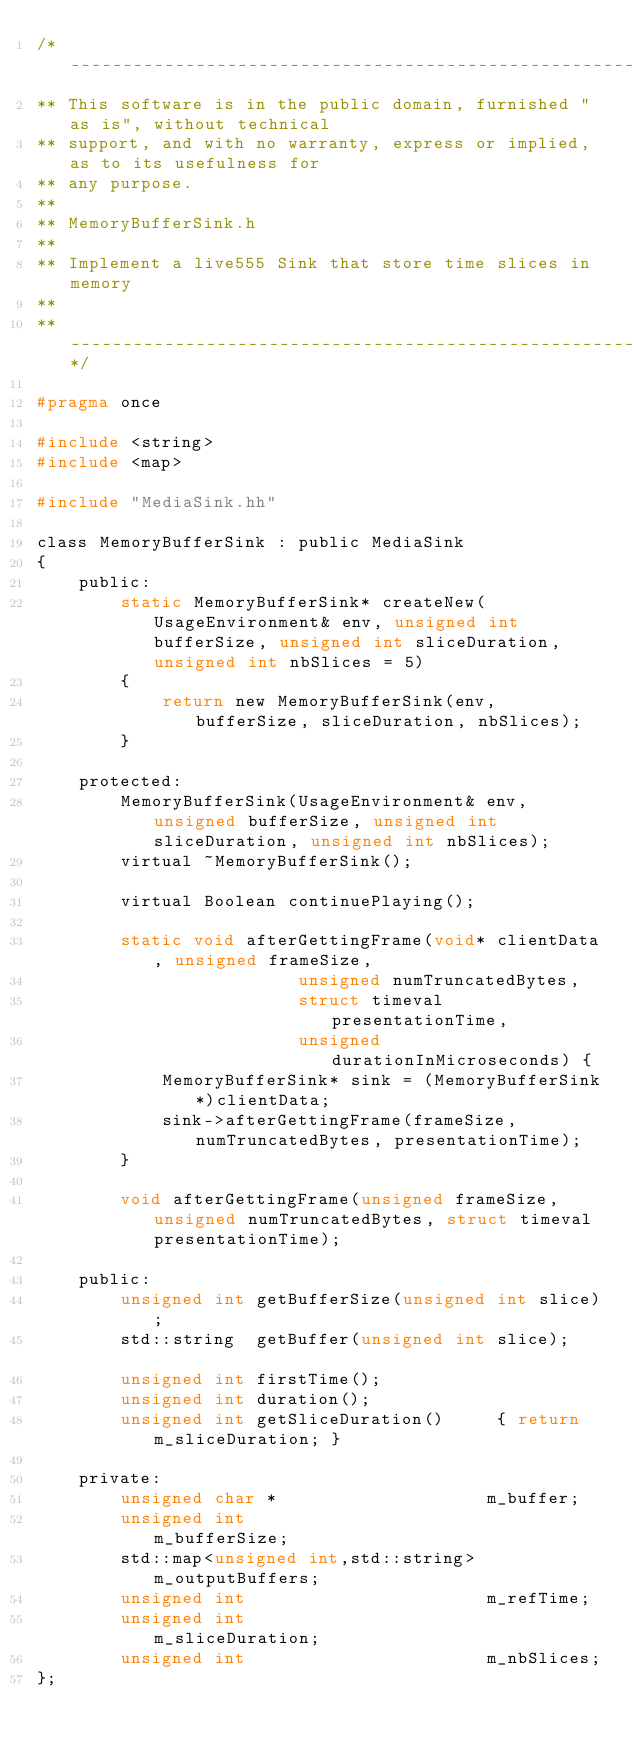<code> <loc_0><loc_0><loc_500><loc_500><_C_>/* ---------------------------------------------------------------------------
** This software is in the public domain, furnished "as is", without technical
** support, and with no warranty, express or implied, as to its usefulness for
** any purpose.
**
** MemoryBufferSink.h
** 
** Implement a live555 Sink that store time slices in memory
**
** -------------------------------------------------------------------------*/

#pragma once

#include <string>
#include <map>

#include "MediaSink.hh"

class MemoryBufferSink : public MediaSink
{
	public:
		static MemoryBufferSink* createNew(UsageEnvironment& env, unsigned int bufferSize, unsigned int sliceDuration, unsigned int nbSlices = 5) 
		{
			return new MemoryBufferSink(env, bufferSize, sliceDuration, nbSlices);
		}
		
	protected:
		MemoryBufferSink(UsageEnvironment& env, unsigned bufferSize, unsigned int sliceDuration, unsigned int nbSlices);
		virtual ~MemoryBufferSink(); 
		
		virtual Boolean continuePlaying();
	
		static void afterGettingFrame(void* clientData, unsigned frameSize,
						 unsigned numTruncatedBytes,
						 struct timeval presentationTime,
						 unsigned durationInMicroseconds) {
			MemoryBufferSink* sink = (MemoryBufferSink*)clientData;
			sink->afterGettingFrame(frameSize, numTruncatedBytes, presentationTime);
		}

		void afterGettingFrame(unsigned frameSize, unsigned numTruncatedBytes, struct timeval presentationTime);
		
	public:
		unsigned int getBufferSize(unsigned int slice);
		std::string  getBuffer(unsigned int slice);			
		unsigned int firstTime();
		unsigned int duration();
		unsigned int getSliceDuration() 	{ return m_sliceDuration; }
		
	private:
		unsigned char *                    m_buffer;
		unsigned int                       m_bufferSize;
		std::map<unsigned int,std::string> m_outputBuffers;
		unsigned int                       m_refTime;
		unsigned int                       m_sliceDuration;
		unsigned int                       m_nbSlices;
};
	
</code> 